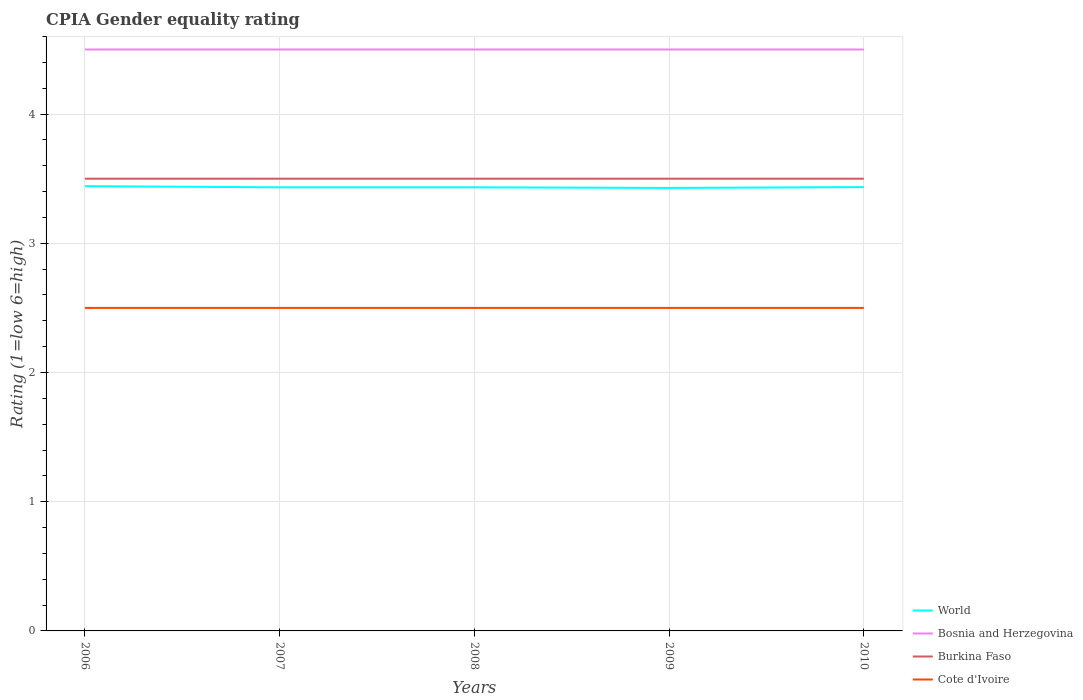Across all years, what is the maximum CPIA rating in World?
Your response must be concise. 3.43. In which year was the CPIA rating in Cote d'Ivoire maximum?
Make the answer very short. 2006. What is the total CPIA rating in Burkina Faso in the graph?
Your response must be concise. 0. What is the difference between the highest and the lowest CPIA rating in World?
Keep it short and to the point. 2. How many lines are there?
Give a very brief answer. 4. What is the difference between two consecutive major ticks on the Y-axis?
Make the answer very short. 1. Are the values on the major ticks of Y-axis written in scientific E-notation?
Offer a very short reply. No. Does the graph contain any zero values?
Make the answer very short. No. Where does the legend appear in the graph?
Make the answer very short. Bottom right. How many legend labels are there?
Give a very brief answer. 4. How are the legend labels stacked?
Keep it short and to the point. Vertical. What is the title of the graph?
Provide a short and direct response. CPIA Gender equality rating. Does "Comoros" appear as one of the legend labels in the graph?
Offer a terse response. No. What is the label or title of the X-axis?
Give a very brief answer. Years. What is the label or title of the Y-axis?
Your answer should be very brief. Rating (1=low 6=high). What is the Rating (1=low 6=high) of World in 2006?
Provide a succinct answer. 3.44. What is the Rating (1=low 6=high) in Bosnia and Herzegovina in 2006?
Keep it short and to the point. 4.5. What is the Rating (1=low 6=high) of Cote d'Ivoire in 2006?
Offer a terse response. 2.5. What is the Rating (1=low 6=high) in World in 2007?
Give a very brief answer. 3.43. What is the Rating (1=low 6=high) in Bosnia and Herzegovina in 2007?
Give a very brief answer. 4.5. What is the Rating (1=low 6=high) of World in 2008?
Offer a terse response. 3.43. What is the Rating (1=low 6=high) of Burkina Faso in 2008?
Provide a short and direct response. 3.5. What is the Rating (1=low 6=high) of Cote d'Ivoire in 2008?
Offer a terse response. 2.5. What is the Rating (1=low 6=high) in World in 2009?
Keep it short and to the point. 3.43. What is the Rating (1=low 6=high) in Cote d'Ivoire in 2009?
Ensure brevity in your answer.  2.5. What is the Rating (1=low 6=high) in World in 2010?
Your answer should be compact. 3.44. What is the Rating (1=low 6=high) of Burkina Faso in 2010?
Offer a terse response. 3.5. What is the Rating (1=low 6=high) of Cote d'Ivoire in 2010?
Your answer should be compact. 2.5. Across all years, what is the maximum Rating (1=low 6=high) in World?
Give a very brief answer. 3.44. Across all years, what is the minimum Rating (1=low 6=high) of World?
Your answer should be compact. 3.43. Across all years, what is the minimum Rating (1=low 6=high) of Bosnia and Herzegovina?
Ensure brevity in your answer.  4.5. Across all years, what is the minimum Rating (1=low 6=high) of Burkina Faso?
Provide a succinct answer. 3.5. Across all years, what is the minimum Rating (1=low 6=high) of Cote d'Ivoire?
Offer a very short reply. 2.5. What is the total Rating (1=low 6=high) in World in the graph?
Give a very brief answer. 17.17. What is the difference between the Rating (1=low 6=high) of World in 2006 and that in 2007?
Keep it short and to the point. 0.01. What is the difference between the Rating (1=low 6=high) of Bosnia and Herzegovina in 2006 and that in 2007?
Give a very brief answer. 0. What is the difference between the Rating (1=low 6=high) of Burkina Faso in 2006 and that in 2007?
Make the answer very short. 0. What is the difference between the Rating (1=low 6=high) of Cote d'Ivoire in 2006 and that in 2007?
Provide a short and direct response. 0. What is the difference between the Rating (1=low 6=high) in World in 2006 and that in 2008?
Offer a very short reply. 0.01. What is the difference between the Rating (1=low 6=high) in Bosnia and Herzegovina in 2006 and that in 2008?
Make the answer very short. 0. What is the difference between the Rating (1=low 6=high) in World in 2006 and that in 2009?
Make the answer very short. 0.01. What is the difference between the Rating (1=low 6=high) in Burkina Faso in 2006 and that in 2009?
Ensure brevity in your answer.  0. What is the difference between the Rating (1=low 6=high) of Cote d'Ivoire in 2006 and that in 2009?
Give a very brief answer. 0. What is the difference between the Rating (1=low 6=high) of World in 2006 and that in 2010?
Your response must be concise. 0.01. What is the difference between the Rating (1=low 6=high) in Bosnia and Herzegovina in 2006 and that in 2010?
Keep it short and to the point. 0. What is the difference between the Rating (1=low 6=high) in Bosnia and Herzegovina in 2007 and that in 2008?
Provide a short and direct response. 0. What is the difference between the Rating (1=low 6=high) of Burkina Faso in 2007 and that in 2008?
Your response must be concise. 0. What is the difference between the Rating (1=low 6=high) in Cote d'Ivoire in 2007 and that in 2008?
Give a very brief answer. 0. What is the difference between the Rating (1=low 6=high) of World in 2007 and that in 2009?
Your response must be concise. 0. What is the difference between the Rating (1=low 6=high) in World in 2007 and that in 2010?
Ensure brevity in your answer.  -0. What is the difference between the Rating (1=low 6=high) of Bosnia and Herzegovina in 2007 and that in 2010?
Offer a terse response. 0. What is the difference between the Rating (1=low 6=high) in Burkina Faso in 2007 and that in 2010?
Your answer should be compact. 0. What is the difference between the Rating (1=low 6=high) in World in 2008 and that in 2009?
Provide a short and direct response. 0. What is the difference between the Rating (1=low 6=high) in Bosnia and Herzegovina in 2008 and that in 2009?
Give a very brief answer. 0. What is the difference between the Rating (1=low 6=high) of Burkina Faso in 2008 and that in 2009?
Keep it short and to the point. 0. What is the difference between the Rating (1=low 6=high) in World in 2008 and that in 2010?
Your answer should be very brief. -0. What is the difference between the Rating (1=low 6=high) in Bosnia and Herzegovina in 2008 and that in 2010?
Offer a very short reply. 0. What is the difference between the Rating (1=low 6=high) in Cote d'Ivoire in 2008 and that in 2010?
Offer a very short reply. 0. What is the difference between the Rating (1=low 6=high) of World in 2009 and that in 2010?
Your answer should be compact. -0.01. What is the difference between the Rating (1=low 6=high) of Bosnia and Herzegovina in 2009 and that in 2010?
Your answer should be compact. 0. What is the difference between the Rating (1=low 6=high) in Burkina Faso in 2009 and that in 2010?
Make the answer very short. 0. What is the difference between the Rating (1=low 6=high) in Cote d'Ivoire in 2009 and that in 2010?
Make the answer very short. 0. What is the difference between the Rating (1=low 6=high) in World in 2006 and the Rating (1=low 6=high) in Bosnia and Herzegovina in 2007?
Offer a very short reply. -1.06. What is the difference between the Rating (1=low 6=high) in World in 2006 and the Rating (1=low 6=high) in Burkina Faso in 2007?
Offer a very short reply. -0.06. What is the difference between the Rating (1=low 6=high) in World in 2006 and the Rating (1=low 6=high) in Cote d'Ivoire in 2007?
Offer a terse response. 0.94. What is the difference between the Rating (1=low 6=high) of Bosnia and Herzegovina in 2006 and the Rating (1=low 6=high) of Burkina Faso in 2007?
Provide a succinct answer. 1. What is the difference between the Rating (1=low 6=high) in Burkina Faso in 2006 and the Rating (1=low 6=high) in Cote d'Ivoire in 2007?
Your answer should be compact. 1. What is the difference between the Rating (1=low 6=high) in World in 2006 and the Rating (1=low 6=high) in Bosnia and Herzegovina in 2008?
Keep it short and to the point. -1.06. What is the difference between the Rating (1=low 6=high) of World in 2006 and the Rating (1=low 6=high) of Burkina Faso in 2008?
Provide a succinct answer. -0.06. What is the difference between the Rating (1=low 6=high) of World in 2006 and the Rating (1=low 6=high) of Cote d'Ivoire in 2008?
Your response must be concise. 0.94. What is the difference between the Rating (1=low 6=high) of World in 2006 and the Rating (1=low 6=high) of Bosnia and Herzegovina in 2009?
Provide a short and direct response. -1.06. What is the difference between the Rating (1=low 6=high) in World in 2006 and the Rating (1=low 6=high) in Burkina Faso in 2009?
Make the answer very short. -0.06. What is the difference between the Rating (1=low 6=high) in World in 2006 and the Rating (1=low 6=high) in Cote d'Ivoire in 2009?
Ensure brevity in your answer.  0.94. What is the difference between the Rating (1=low 6=high) of Bosnia and Herzegovina in 2006 and the Rating (1=low 6=high) of Burkina Faso in 2009?
Offer a terse response. 1. What is the difference between the Rating (1=low 6=high) of Burkina Faso in 2006 and the Rating (1=low 6=high) of Cote d'Ivoire in 2009?
Offer a very short reply. 1. What is the difference between the Rating (1=low 6=high) in World in 2006 and the Rating (1=low 6=high) in Bosnia and Herzegovina in 2010?
Your answer should be very brief. -1.06. What is the difference between the Rating (1=low 6=high) in World in 2006 and the Rating (1=low 6=high) in Burkina Faso in 2010?
Offer a very short reply. -0.06. What is the difference between the Rating (1=low 6=high) of World in 2006 and the Rating (1=low 6=high) of Cote d'Ivoire in 2010?
Your answer should be very brief. 0.94. What is the difference between the Rating (1=low 6=high) of Bosnia and Herzegovina in 2006 and the Rating (1=low 6=high) of Burkina Faso in 2010?
Provide a succinct answer. 1. What is the difference between the Rating (1=low 6=high) in Bosnia and Herzegovina in 2006 and the Rating (1=low 6=high) in Cote d'Ivoire in 2010?
Your response must be concise. 2. What is the difference between the Rating (1=low 6=high) of Burkina Faso in 2006 and the Rating (1=low 6=high) of Cote d'Ivoire in 2010?
Give a very brief answer. 1. What is the difference between the Rating (1=low 6=high) in World in 2007 and the Rating (1=low 6=high) in Bosnia and Herzegovina in 2008?
Make the answer very short. -1.07. What is the difference between the Rating (1=low 6=high) of World in 2007 and the Rating (1=low 6=high) of Burkina Faso in 2008?
Your answer should be compact. -0.07. What is the difference between the Rating (1=low 6=high) in Bosnia and Herzegovina in 2007 and the Rating (1=low 6=high) in Burkina Faso in 2008?
Offer a very short reply. 1. What is the difference between the Rating (1=low 6=high) in Burkina Faso in 2007 and the Rating (1=low 6=high) in Cote d'Ivoire in 2008?
Give a very brief answer. 1. What is the difference between the Rating (1=low 6=high) in World in 2007 and the Rating (1=low 6=high) in Bosnia and Herzegovina in 2009?
Provide a short and direct response. -1.07. What is the difference between the Rating (1=low 6=high) in World in 2007 and the Rating (1=low 6=high) in Burkina Faso in 2009?
Ensure brevity in your answer.  -0.07. What is the difference between the Rating (1=low 6=high) in Bosnia and Herzegovina in 2007 and the Rating (1=low 6=high) in Cote d'Ivoire in 2009?
Ensure brevity in your answer.  2. What is the difference between the Rating (1=low 6=high) in Burkina Faso in 2007 and the Rating (1=low 6=high) in Cote d'Ivoire in 2009?
Offer a terse response. 1. What is the difference between the Rating (1=low 6=high) of World in 2007 and the Rating (1=low 6=high) of Bosnia and Herzegovina in 2010?
Give a very brief answer. -1.07. What is the difference between the Rating (1=low 6=high) in World in 2007 and the Rating (1=low 6=high) in Burkina Faso in 2010?
Your answer should be very brief. -0.07. What is the difference between the Rating (1=low 6=high) in Bosnia and Herzegovina in 2007 and the Rating (1=low 6=high) in Burkina Faso in 2010?
Your answer should be compact. 1. What is the difference between the Rating (1=low 6=high) in Bosnia and Herzegovina in 2007 and the Rating (1=low 6=high) in Cote d'Ivoire in 2010?
Offer a very short reply. 2. What is the difference between the Rating (1=low 6=high) of World in 2008 and the Rating (1=low 6=high) of Bosnia and Herzegovina in 2009?
Keep it short and to the point. -1.07. What is the difference between the Rating (1=low 6=high) in World in 2008 and the Rating (1=low 6=high) in Burkina Faso in 2009?
Ensure brevity in your answer.  -0.07. What is the difference between the Rating (1=low 6=high) of Bosnia and Herzegovina in 2008 and the Rating (1=low 6=high) of Burkina Faso in 2009?
Ensure brevity in your answer.  1. What is the difference between the Rating (1=low 6=high) in Bosnia and Herzegovina in 2008 and the Rating (1=low 6=high) in Cote d'Ivoire in 2009?
Give a very brief answer. 2. What is the difference between the Rating (1=low 6=high) of Burkina Faso in 2008 and the Rating (1=low 6=high) of Cote d'Ivoire in 2009?
Provide a short and direct response. 1. What is the difference between the Rating (1=low 6=high) of World in 2008 and the Rating (1=low 6=high) of Bosnia and Herzegovina in 2010?
Keep it short and to the point. -1.07. What is the difference between the Rating (1=low 6=high) of World in 2008 and the Rating (1=low 6=high) of Burkina Faso in 2010?
Offer a terse response. -0.07. What is the difference between the Rating (1=low 6=high) in World in 2008 and the Rating (1=low 6=high) in Cote d'Ivoire in 2010?
Ensure brevity in your answer.  0.93. What is the difference between the Rating (1=low 6=high) in Bosnia and Herzegovina in 2008 and the Rating (1=low 6=high) in Cote d'Ivoire in 2010?
Ensure brevity in your answer.  2. What is the difference between the Rating (1=low 6=high) of World in 2009 and the Rating (1=low 6=high) of Bosnia and Herzegovina in 2010?
Keep it short and to the point. -1.07. What is the difference between the Rating (1=low 6=high) of World in 2009 and the Rating (1=low 6=high) of Burkina Faso in 2010?
Provide a succinct answer. -0.07. What is the difference between the Rating (1=low 6=high) in World in 2009 and the Rating (1=low 6=high) in Cote d'Ivoire in 2010?
Give a very brief answer. 0.93. What is the difference between the Rating (1=low 6=high) of Bosnia and Herzegovina in 2009 and the Rating (1=low 6=high) of Cote d'Ivoire in 2010?
Provide a succinct answer. 2. What is the difference between the Rating (1=low 6=high) of Burkina Faso in 2009 and the Rating (1=low 6=high) of Cote d'Ivoire in 2010?
Give a very brief answer. 1. What is the average Rating (1=low 6=high) in World per year?
Your response must be concise. 3.43. What is the average Rating (1=low 6=high) of Bosnia and Herzegovina per year?
Ensure brevity in your answer.  4.5. What is the average Rating (1=low 6=high) of Burkina Faso per year?
Provide a succinct answer. 3.5. What is the average Rating (1=low 6=high) in Cote d'Ivoire per year?
Your answer should be compact. 2.5. In the year 2006, what is the difference between the Rating (1=low 6=high) in World and Rating (1=low 6=high) in Bosnia and Herzegovina?
Provide a short and direct response. -1.06. In the year 2006, what is the difference between the Rating (1=low 6=high) in World and Rating (1=low 6=high) in Burkina Faso?
Your answer should be very brief. -0.06. In the year 2006, what is the difference between the Rating (1=low 6=high) of World and Rating (1=low 6=high) of Cote d'Ivoire?
Make the answer very short. 0.94. In the year 2006, what is the difference between the Rating (1=low 6=high) in Bosnia and Herzegovina and Rating (1=low 6=high) in Cote d'Ivoire?
Ensure brevity in your answer.  2. In the year 2006, what is the difference between the Rating (1=low 6=high) in Burkina Faso and Rating (1=low 6=high) in Cote d'Ivoire?
Provide a succinct answer. 1. In the year 2007, what is the difference between the Rating (1=low 6=high) of World and Rating (1=low 6=high) of Bosnia and Herzegovina?
Your answer should be compact. -1.07. In the year 2007, what is the difference between the Rating (1=low 6=high) of World and Rating (1=low 6=high) of Burkina Faso?
Provide a short and direct response. -0.07. In the year 2007, what is the difference between the Rating (1=low 6=high) of World and Rating (1=low 6=high) of Cote d'Ivoire?
Give a very brief answer. 0.93. In the year 2007, what is the difference between the Rating (1=low 6=high) in Bosnia and Herzegovina and Rating (1=low 6=high) in Burkina Faso?
Provide a succinct answer. 1. In the year 2007, what is the difference between the Rating (1=low 6=high) in Burkina Faso and Rating (1=low 6=high) in Cote d'Ivoire?
Provide a succinct answer. 1. In the year 2008, what is the difference between the Rating (1=low 6=high) of World and Rating (1=low 6=high) of Bosnia and Herzegovina?
Your answer should be very brief. -1.07. In the year 2008, what is the difference between the Rating (1=low 6=high) in World and Rating (1=low 6=high) in Burkina Faso?
Offer a terse response. -0.07. In the year 2008, what is the difference between the Rating (1=low 6=high) of World and Rating (1=low 6=high) of Cote d'Ivoire?
Your response must be concise. 0.93. In the year 2008, what is the difference between the Rating (1=low 6=high) of Bosnia and Herzegovina and Rating (1=low 6=high) of Burkina Faso?
Provide a short and direct response. 1. In the year 2009, what is the difference between the Rating (1=low 6=high) in World and Rating (1=low 6=high) in Bosnia and Herzegovina?
Offer a very short reply. -1.07. In the year 2009, what is the difference between the Rating (1=low 6=high) of World and Rating (1=low 6=high) of Burkina Faso?
Ensure brevity in your answer.  -0.07. In the year 2009, what is the difference between the Rating (1=low 6=high) in World and Rating (1=low 6=high) in Cote d'Ivoire?
Provide a short and direct response. 0.93. In the year 2010, what is the difference between the Rating (1=low 6=high) of World and Rating (1=low 6=high) of Bosnia and Herzegovina?
Ensure brevity in your answer.  -1.06. In the year 2010, what is the difference between the Rating (1=low 6=high) in World and Rating (1=low 6=high) in Burkina Faso?
Give a very brief answer. -0.06. In the year 2010, what is the difference between the Rating (1=low 6=high) in World and Rating (1=low 6=high) in Cote d'Ivoire?
Offer a very short reply. 0.94. In the year 2010, what is the difference between the Rating (1=low 6=high) in Bosnia and Herzegovina and Rating (1=low 6=high) in Burkina Faso?
Your response must be concise. 1. In the year 2010, what is the difference between the Rating (1=low 6=high) of Bosnia and Herzegovina and Rating (1=low 6=high) of Cote d'Ivoire?
Ensure brevity in your answer.  2. What is the ratio of the Rating (1=low 6=high) in World in 2006 to that in 2007?
Make the answer very short. 1. What is the ratio of the Rating (1=low 6=high) in Bosnia and Herzegovina in 2006 to that in 2007?
Provide a short and direct response. 1. What is the ratio of the Rating (1=low 6=high) of Burkina Faso in 2006 to that in 2007?
Offer a very short reply. 1. What is the ratio of the Rating (1=low 6=high) of Bosnia and Herzegovina in 2006 to that in 2008?
Ensure brevity in your answer.  1. What is the ratio of the Rating (1=low 6=high) in World in 2006 to that in 2009?
Provide a short and direct response. 1. What is the ratio of the Rating (1=low 6=high) in Burkina Faso in 2006 to that in 2009?
Your answer should be compact. 1. What is the ratio of the Rating (1=low 6=high) in Cote d'Ivoire in 2006 to that in 2009?
Offer a very short reply. 1. What is the ratio of the Rating (1=low 6=high) of World in 2006 to that in 2010?
Make the answer very short. 1. What is the ratio of the Rating (1=low 6=high) in Cote d'Ivoire in 2006 to that in 2010?
Your response must be concise. 1. What is the ratio of the Rating (1=low 6=high) in World in 2007 to that in 2008?
Ensure brevity in your answer.  1. What is the ratio of the Rating (1=low 6=high) of Burkina Faso in 2007 to that in 2008?
Your answer should be compact. 1. What is the ratio of the Rating (1=low 6=high) in Cote d'Ivoire in 2007 to that in 2008?
Give a very brief answer. 1. What is the ratio of the Rating (1=low 6=high) in World in 2007 to that in 2009?
Make the answer very short. 1. What is the ratio of the Rating (1=low 6=high) of Bosnia and Herzegovina in 2007 to that in 2009?
Offer a terse response. 1. What is the ratio of the Rating (1=low 6=high) of Burkina Faso in 2007 to that in 2009?
Your answer should be compact. 1. What is the ratio of the Rating (1=low 6=high) in Cote d'Ivoire in 2007 to that in 2010?
Your response must be concise. 1. What is the ratio of the Rating (1=low 6=high) in World in 2008 to that in 2009?
Your answer should be compact. 1. What is the ratio of the Rating (1=low 6=high) of Bosnia and Herzegovina in 2008 to that in 2009?
Give a very brief answer. 1. What is the ratio of the Rating (1=low 6=high) of Burkina Faso in 2008 to that in 2009?
Your answer should be compact. 1. What is the ratio of the Rating (1=low 6=high) of World in 2008 to that in 2010?
Provide a short and direct response. 1. What is the ratio of the Rating (1=low 6=high) in Burkina Faso in 2008 to that in 2010?
Your answer should be very brief. 1. What is the ratio of the Rating (1=low 6=high) of World in 2009 to that in 2010?
Provide a short and direct response. 1. What is the ratio of the Rating (1=low 6=high) in Bosnia and Herzegovina in 2009 to that in 2010?
Provide a succinct answer. 1. What is the ratio of the Rating (1=low 6=high) in Cote d'Ivoire in 2009 to that in 2010?
Provide a short and direct response. 1. What is the difference between the highest and the second highest Rating (1=low 6=high) in World?
Keep it short and to the point. 0.01. What is the difference between the highest and the second highest Rating (1=low 6=high) of Bosnia and Herzegovina?
Provide a succinct answer. 0. What is the difference between the highest and the second highest Rating (1=low 6=high) of Burkina Faso?
Provide a succinct answer. 0. What is the difference between the highest and the second highest Rating (1=low 6=high) of Cote d'Ivoire?
Provide a short and direct response. 0. What is the difference between the highest and the lowest Rating (1=low 6=high) of World?
Ensure brevity in your answer.  0.01. What is the difference between the highest and the lowest Rating (1=low 6=high) of Cote d'Ivoire?
Offer a terse response. 0. 